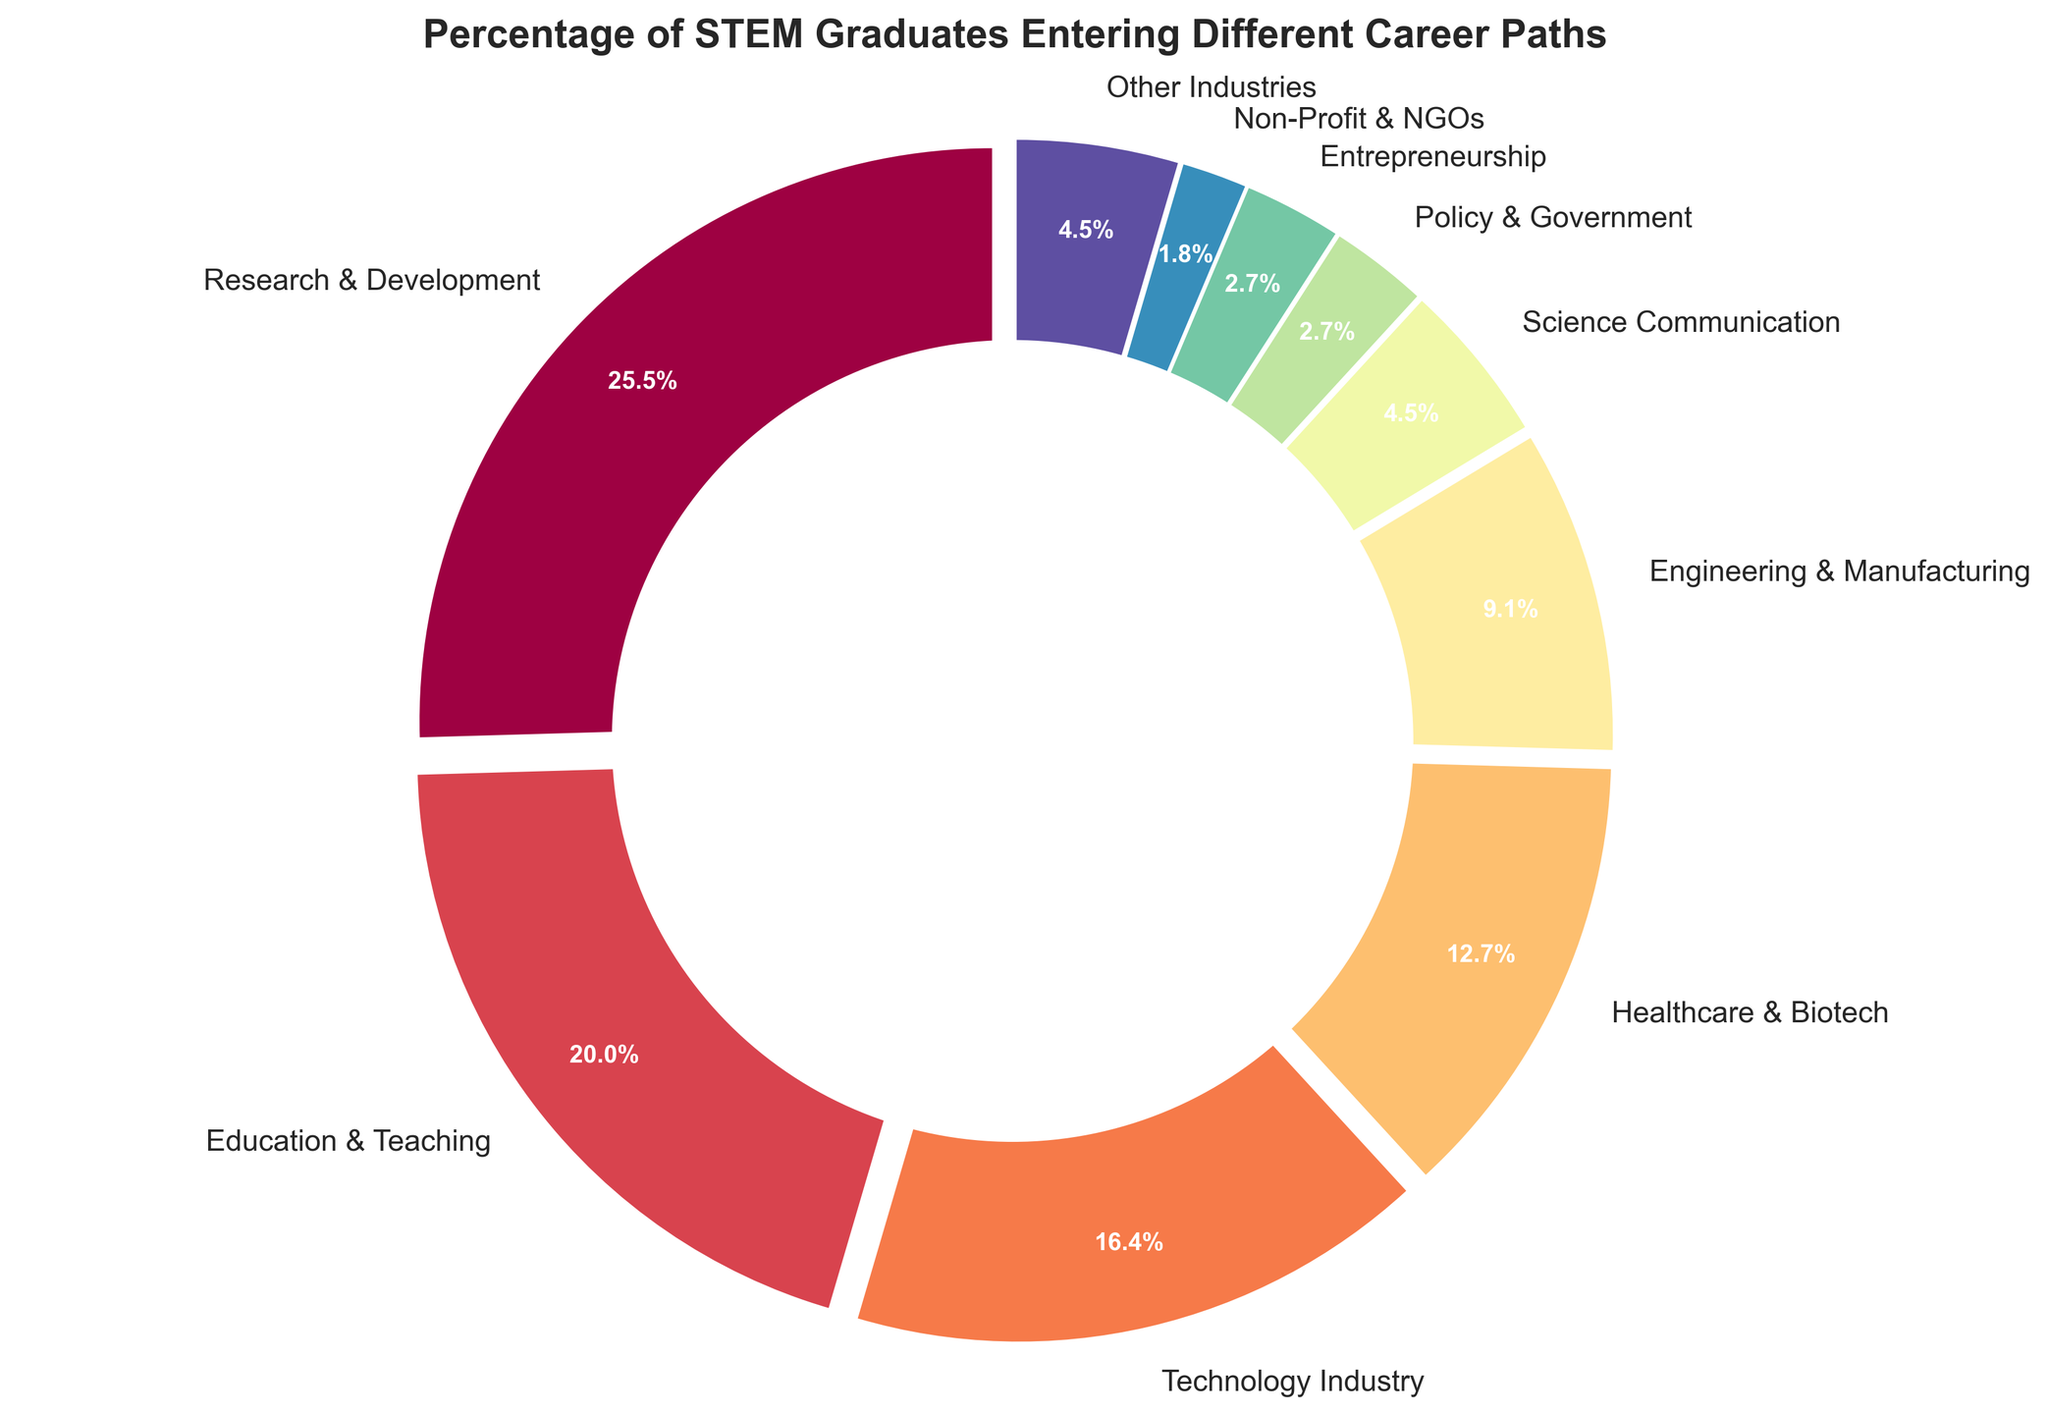What percentage of STEM graduates enter Research & Development? To find the percentage of graduates entering Research & Development, look for the "Research & Development" label in the pie chart and read the percentage displayed next to it.
Answer: 28% What is the combined percentage of graduates entering Technology Industry and Engineering & Manufacturing? To find the combined percentage, add the percentage of graduates in Technology Industry (18%) and Engineering & Manufacturing (10%).
Answer: 28% Which career path has a higher percentage, Education & Teaching or Healthcare & Biotech? Compare the percentages next to the labels "Education & Teaching" (22%) and "Healthcare & Biotech" (14%).
Answer: Education & Teaching By how much does the percentage of graduates entering Research & Development exceed those entering Policy & Government? Subtract the percentage of graduates in Policy & Government (3%) from those in Research & Development (28%).
Answer: 25% Which career path occupies the smallest segment of the pie chart? Look for the career path with the smallest percentage value and segment in the pie chart.
Answer: Non-Profit & NGOs Is the percentage of graduates entering Science Communication closer to the percentage for Technology Industry or Policy & Government? Compare the percentage of Science Communication (5%) with those of Technology Industry (18%) and Policy & Government (3%).
Answer: Policy & Government What is the total percentage of STEM graduates entering non-technical fields (Science Communication, Policy & Government, Non-Profit & NGOs, Other Industries)? Add the percentages for Science Communication (5%), Policy & Government (3%), Non-Profit & NGOs (2%), and Other Industries (5%).
Answer: 15% How many categories have a percentage greater than 10%? Count the career paths with a percentage greater than 10% by looking at the pie chart segments labeled with more than 10%.
Answer: 5 What color represents the Education & Teaching segment in the pie chart? Identify the color used for the segment labeled "Education & Teaching" in the pie chart.
Answer: Depending on the spectral colormap, typically a specific shade such as orange or yellow (color interpretation varies) Out of the career paths depicted, which two have an equal percentage of graduates? Look for segments in the pie chart with the same percentage values.
Answer: Policy & Government and Entrepreneurship 